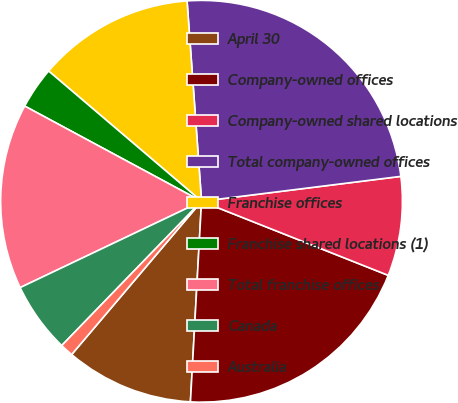Convert chart to OTSL. <chart><loc_0><loc_0><loc_500><loc_500><pie_chart><fcel>April 30<fcel>Company-owned offices<fcel>Company-owned shared locations<fcel>Total company-owned offices<fcel>Franchise offices<fcel>Franchise shared locations (1)<fcel>Total franchise offices<fcel>Canada<fcel>Australia<nl><fcel>10.31%<fcel>19.87%<fcel>7.99%<fcel>24.17%<fcel>12.62%<fcel>3.37%<fcel>14.93%<fcel>5.68%<fcel>1.06%<nl></chart> 